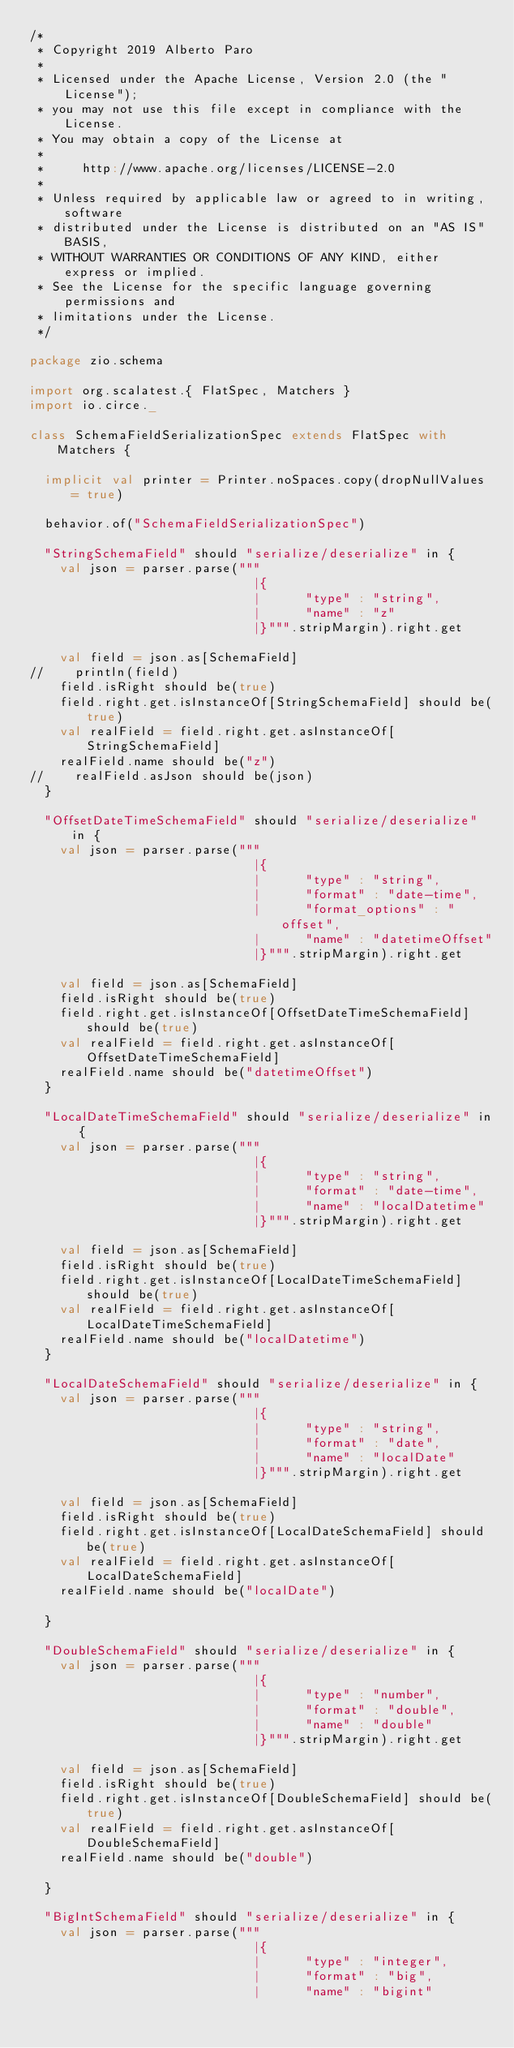<code> <loc_0><loc_0><loc_500><loc_500><_Scala_>/*
 * Copyright 2019 Alberto Paro
 *
 * Licensed under the Apache License, Version 2.0 (the "License");
 * you may not use this file except in compliance with the License.
 * You may obtain a copy of the License at
 *
 *     http://www.apache.org/licenses/LICENSE-2.0
 *
 * Unless required by applicable law or agreed to in writing, software
 * distributed under the License is distributed on an "AS IS" BASIS,
 * WITHOUT WARRANTIES OR CONDITIONS OF ANY KIND, either express or implied.
 * See the License for the specific language governing permissions and
 * limitations under the License.
 */

package zio.schema

import org.scalatest.{ FlatSpec, Matchers }
import io.circe._

class SchemaFieldSerializationSpec extends FlatSpec with Matchers {

  implicit val printer = Printer.noSpaces.copy(dropNullValues = true)

  behavior.of("SchemaFieldSerializationSpec")

  "StringSchemaField" should "serialize/deserialize" in {
    val json = parser.parse("""
                              |{
                              |      "type" : "string",
                              |      "name" : "z"
                              |}""".stripMargin).right.get

    val field = json.as[SchemaField]
//    println(field)
    field.isRight should be(true)
    field.right.get.isInstanceOf[StringSchemaField] should be(true)
    val realField = field.right.get.asInstanceOf[StringSchemaField]
    realField.name should be("z")
//    realField.asJson should be(json)
  }

  "OffsetDateTimeSchemaField" should "serialize/deserialize" in {
    val json = parser.parse("""
                              |{
                              |      "type" : "string",
                              |      "format" : "date-time",
                              |      "format_options" : "offset",
                              |      "name" : "datetimeOffset"
                              |}""".stripMargin).right.get

    val field = json.as[SchemaField]
    field.isRight should be(true)
    field.right.get.isInstanceOf[OffsetDateTimeSchemaField] should be(true)
    val realField = field.right.get.asInstanceOf[OffsetDateTimeSchemaField]
    realField.name should be("datetimeOffset")
  }

  "LocalDateTimeSchemaField" should "serialize/deserialize" in {
    val json = parser.parse("""
                              |{
                              |      "type" : "string",
                              |      "format" : "date-time",
                              |      "name" : "localDatetime"
                              |}""".stripMargin).right.get

    val field = json.as[SchemaField]
    field.isRight should be(true)
    field.right.get.isInstanceOf[LocalDateTimeSchemaField] should be(true)
    val realField = field.right.get.asInstanceOf[LocalDateTimeSchemaField]
    realField.name should be("localDatetime")
  }

  "LocalDateSchemaField" should "serialize/deserialize" in {
    val json = parser.parse("""
                              |{
                              |      "type" : "string",
                              |      "format" : "date",
                              |      "name" : "localDate"
                              |}""".stripMargin).right.get

    val field = json.as[SchemaField]
    field.isRight should be(true)
    field.right.get.isInstanceOf[LocalDateSchemaField] should be(true)
    val realField = field.right.get.asInstanceOf[LocalDateSchemaField]
    realField.name should be("localDate")

  }

  "DoubleSchemaField" should "serialize/deserialize" in {
    val json = parser.parse("""
                              |{
                              |      "type" : "number",
                              |      "format" : "double",
                              |      "name" : "double"
                              |}""".stripMargin).right.get

    val field = json.as[SchemaField]
    field.isRight should be(true)
    field.right.get.isInstanceOf[DoubleSchemaField] should be(true)
    val realField = field.right.get.asInstanceOf[DoubleSchemaField]
    realField.name should be("double")

  }

  "BigIntSchemaField" should "serialize/deserialize" in {
    val json = parser.parse("""
                              |{
                              |      "type" : "integer",
                              |      "format" : "big",
                              |      "name" : "bigint"</code> 